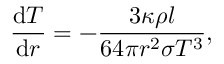<formula> <loc_0><loc_0><loc_500><loc_500>{ \frac { { d } T } { { d } r } } = - { \frac { 3 \kappa \rho l } { 6 4 \pi r ^ { 2 } \sigma T ^ { 3 } } } ,</formula> 